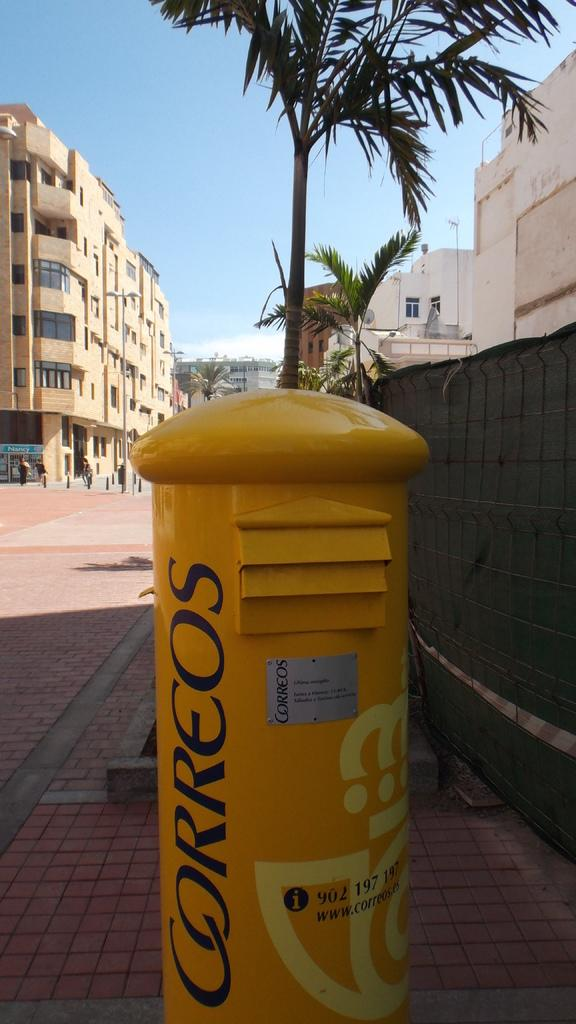<image>
Write a terse but informative summary of the picture. Yellow stand outside which says "Correos" on it. 